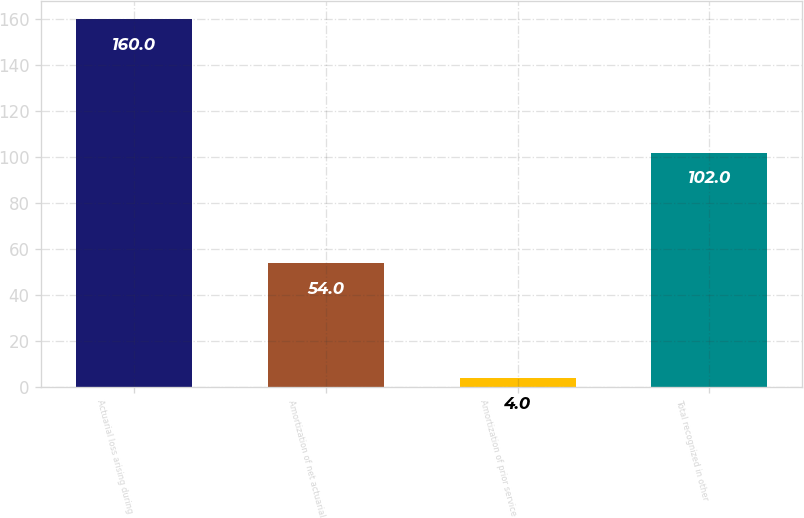<chart> <loc_0><loc_0><loc_500><loc_500><bar_chart><fcel>Actuarial loss arising during<fcel>Amortization of net actuarial<fcel>Amortization of prior service<fcel>Total recognized in other<nl><fcel>160<fcel>54<fcel>4<fcel>102<nl></chart> 